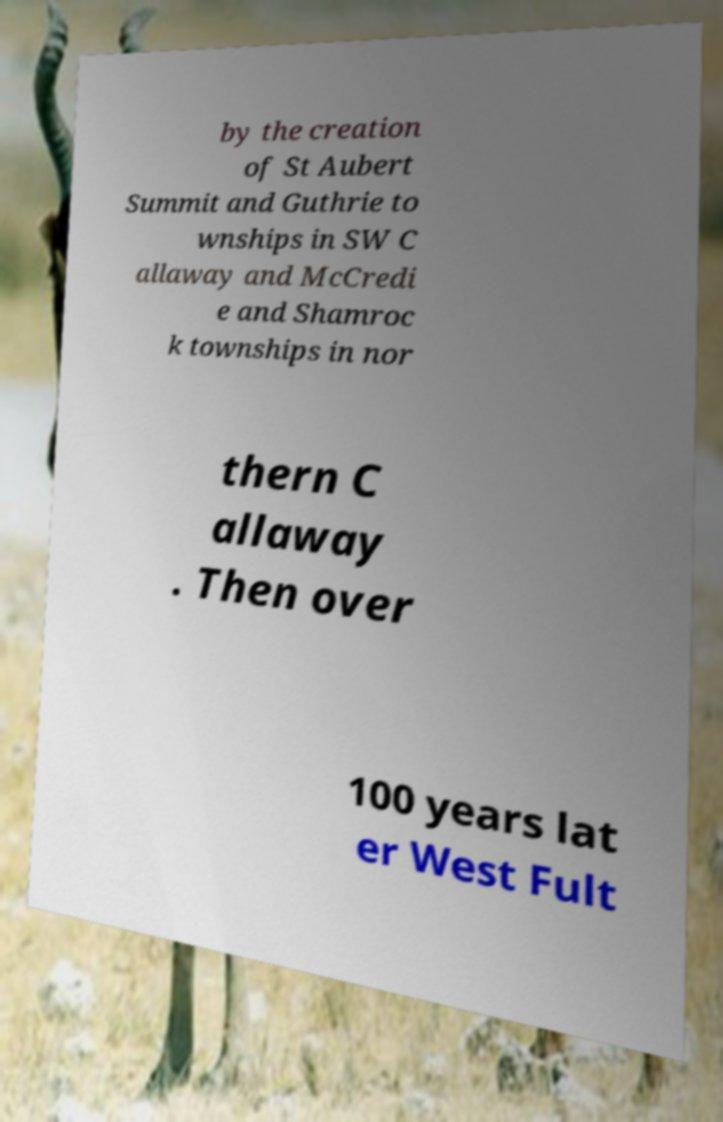There's text embedded in this image that I need extracted. Can you transcribe it verbatim? by the creation of St Aubert Summit and Guthrie to wnships in SW C allaway and McCredi e and Shamroc k townships in nor thern C allaway . Then over 100 years lat er West Fult 